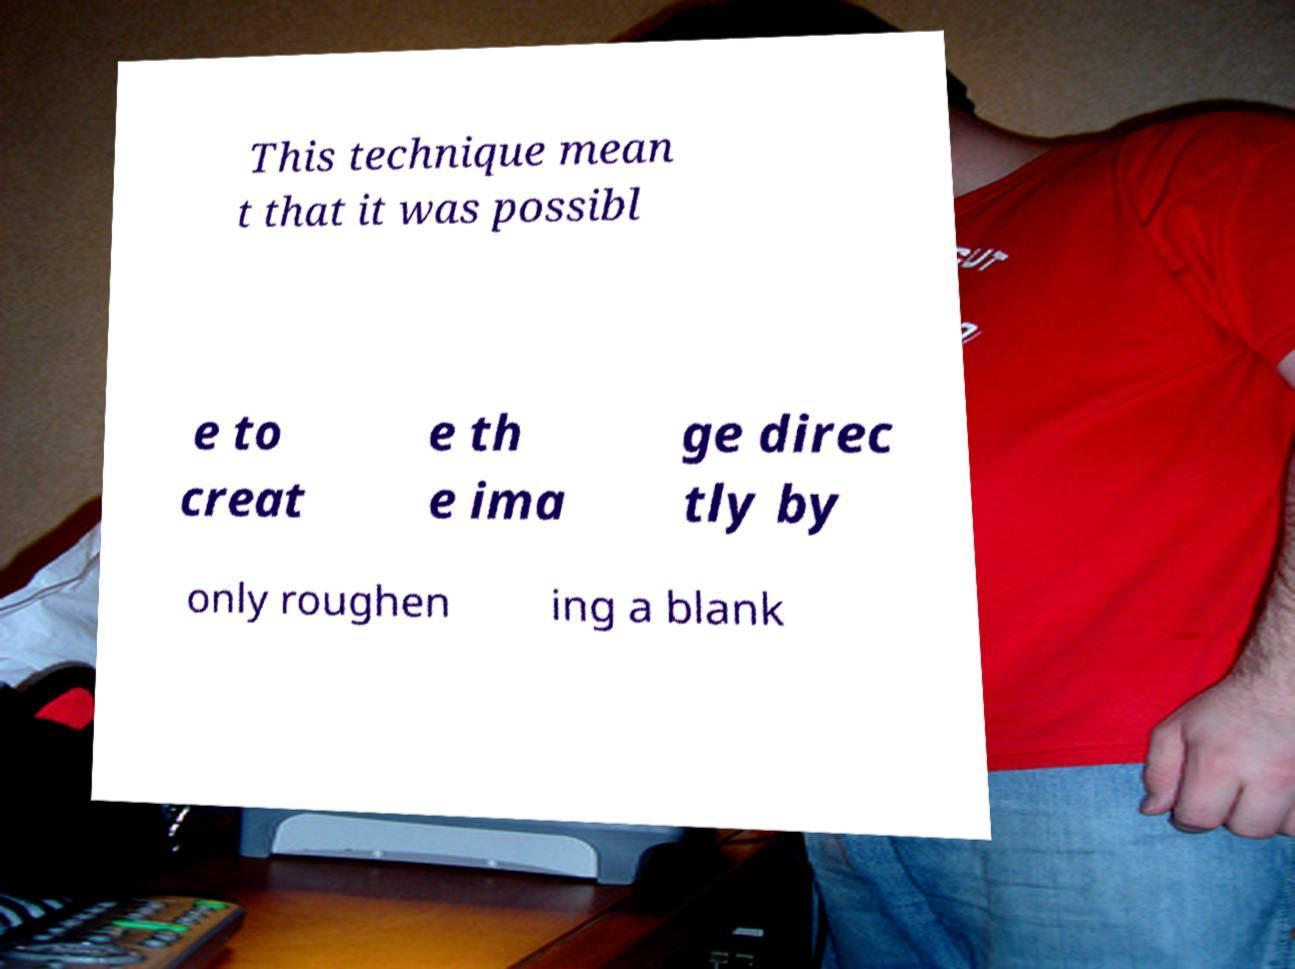Could you extract and type out the text from this image? This technique mean t that it was possibl e to creat e th e ima ge direc tly by only roughen ing a blank 